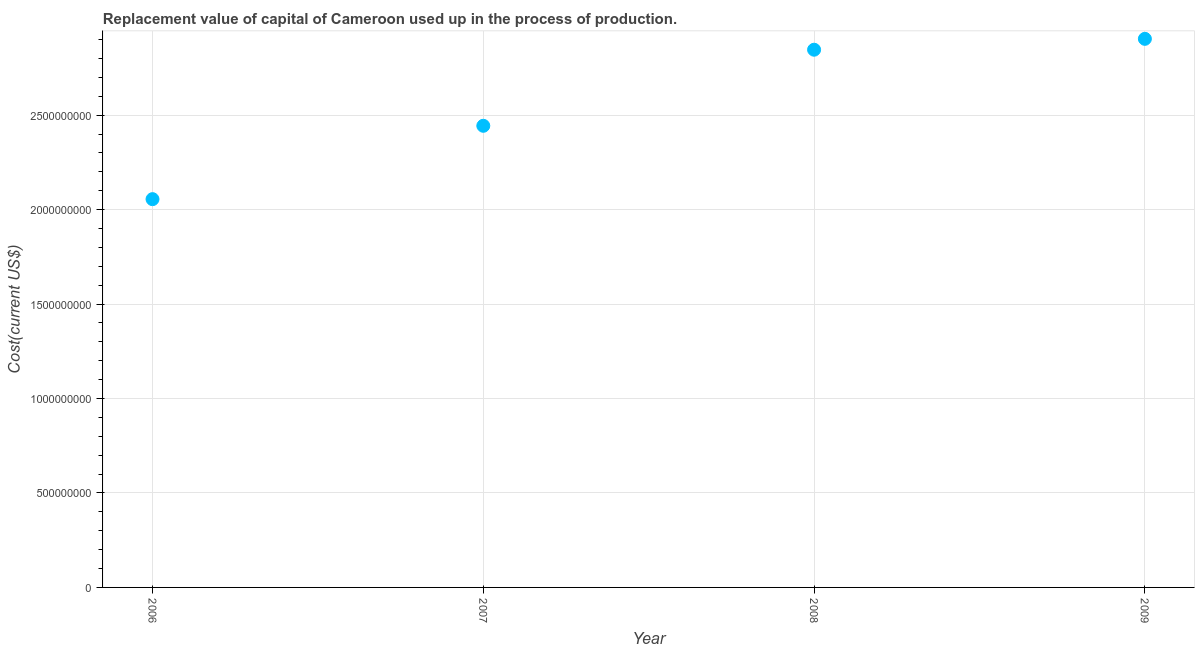What is the consumption of fixed capital in 2007?
Your response must be concise. 2.44e+09. Across all years, what is the maximum consumption of fixed capital?
Your answer should be compact. 2.90e+09. Across all years, what is the minimum consumption of fixed capital?
Your response must be concise. 2.06e+09. In which year was the consumption of fixed capital minimum?
Provide a short and direct response. 2006. What is the sum of the consumption of fixed capital?
Offer a terse response. 1.03e+1. What is the difference between the consumption of fixed capital in 2006 and 2008?
Your answer should be compact. -7.91e+08. What is the average consumption of fixed capital per year?
Your answer should be compact. 2.56e+09. What is the median consumption of fixed capital?
Offer a very short reply. 2.65e+09. In how many years, is the consumption of fixed capital greater than 100000000 US$?
Offer a very short reply. 4. What is the ratio of the consumption of fixed capital in 2006 to that in 2008?
Ensure brevity in your answer.  0.72. Is the difference between the consumption of fixed capital in 2007 and 2009 greater than the difference between any two years?
Give a very brief answer. No. What is the difference between the highest and the second highest consumption of fixed capital?
Keep it short and to the point. 5.76e+07. What is the difference between the highest and the lowest consumption of fixed capital?
Make the answer very short. 8.49e+08. How many dotlines are there?
Ensure brevity in your answer.  1. What is the difference between two consecutive major ticks on the Y-axis?
Give a very brief answer. 5.00e+08. Does the graph contain grids?
Offer a very short reply. Yes. What is the title of the graph?
Provide a succinct answer. Replacement value of capital of Cameroon used up in the process of production. What is the label or title of the X-axis?
Offer a very short reply. Year. What is the label or title of the Y-axis?
Your answer should be compact. Cost(current US$). What is the Cost(current US$) in 2006?
Offer a very short reply. 2.06e+09. What is the Cost(current US$) in 2007?
Provide a succinct answer. 2.44e+09. What is the Cost(current US$) in 2008?
Keep it short and to the point. 2.85e+09. What is the Cost(current US$) in 2009?
Keep it short and to the point. 2.90e+09. What is the difference between the Cost(current US$) in 2006 and 2007?
Provide a short and direct response. -3.88e+08. What is the difference between the Cost(current US$) in 2006 and 2008?
Provide a succinct answer. -7.91e+08. What is the difference between the Cost(current US$) in 2006 and 2009?
Provide a succinct answer. -8.49e+08. What is the difference between the Cost(current US$) in 2007 and 2008?
Your answer should be compact. -4.03e+08. What is the difference between the Cost(current US$) in 2007 and 2009?
Your answer should be very brief. -4.60e+08. What is the difference between the Cost(current US$) in 2008 and 2009?
Your answer should be very brief. -5.76e+07. What is the ratio of the Cost(current US$) in 2006 to that in 2007?
Provide a short and direct response. 0.84. What is the ratio of the Cost(current US$) in 2006 to that in 2008?
Provide a short and direct response. 0.72. What is the ratio of the Cost(current US$) in 2006 to that in 2009?
Make the answer very short. 0.71. What is the ratio of the Cost(current US$) in 2007 to that in 2008?
Offer a very short reply. 0.86. What is the ratio of the Cost(current US$) in 2007 to that in 2009?
Your answer should be very brief. 0.84. What is the ratio of the Cost(current US$) in 2008 to that in 2009?
Provide a short and direct response. 0.98. 